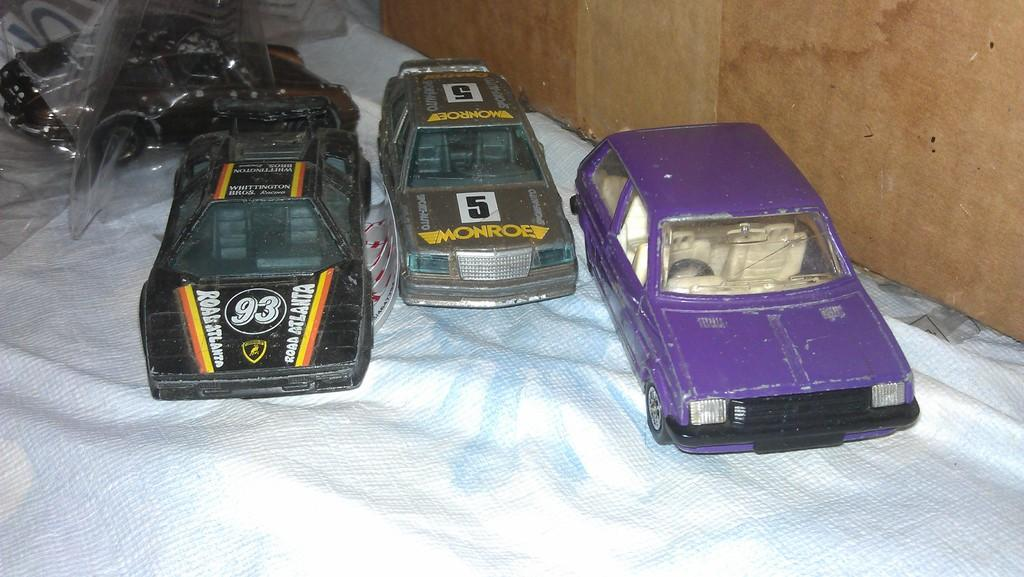How many cars are visible in the image? There are three cars in the image. Where are the cars located? The cars are on a mat in the image. What can be seen on the right side of the image? There is a wall on the right side of the image. Can you describe any additional details about the toy cars? There is a cover on a toy car in the background of the image. What type of advice is being given by the pocket in the image? There is no pocket present in the image, and therefore no advice can be given by it. 